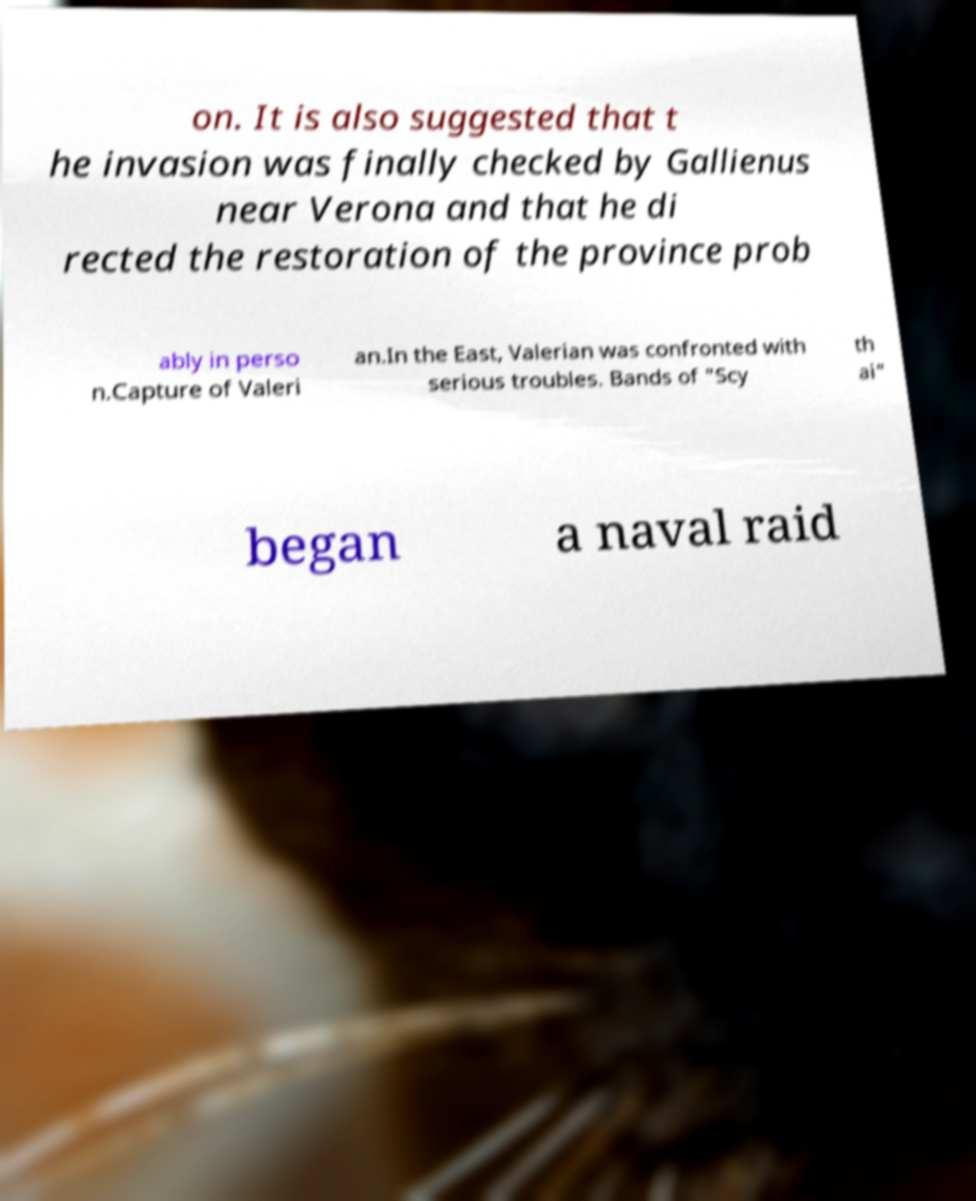Please identify and transcribe the text found in this image. on. It is also suggested that t he invasion was finally checked by Gallienus near Verona and that he di rected the restoration of the province prob ably in perso n.Capture of Valeri an.In the East, Valerian was confronted with serious troubles. Bands of "Scy th ai" began a naval raid 